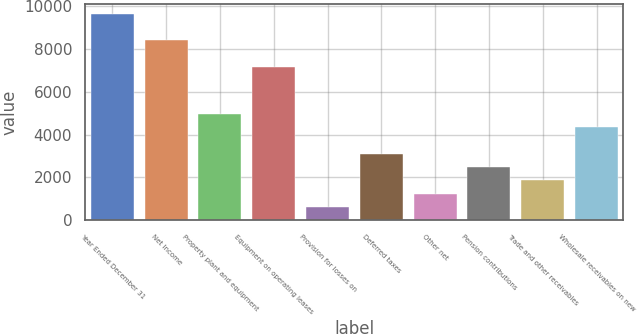<chart> <loc_0><loc_0><loc_500><loc_500><bar_chart><fcel>Year Ended December 31<fcel>Net Income<fcel>Property plant and equipment<fcel>Equipment on operating leases<fcel>Provision for losses on<fcel>Deferred taxes<fcel>Other net<fcel>Pension contributions<fcel>Trade and other receivables<fcel>Wholesale receivables on new<nl><fcel>9651.71<fcel>8406.47<fcel>4982.06<fcel>7161.23<fcel>623.72<fcel>3114.2<fcel>1246.34<fcel>2491.58<fcel>1868.96<fcel>4359.44<nl></chart> 